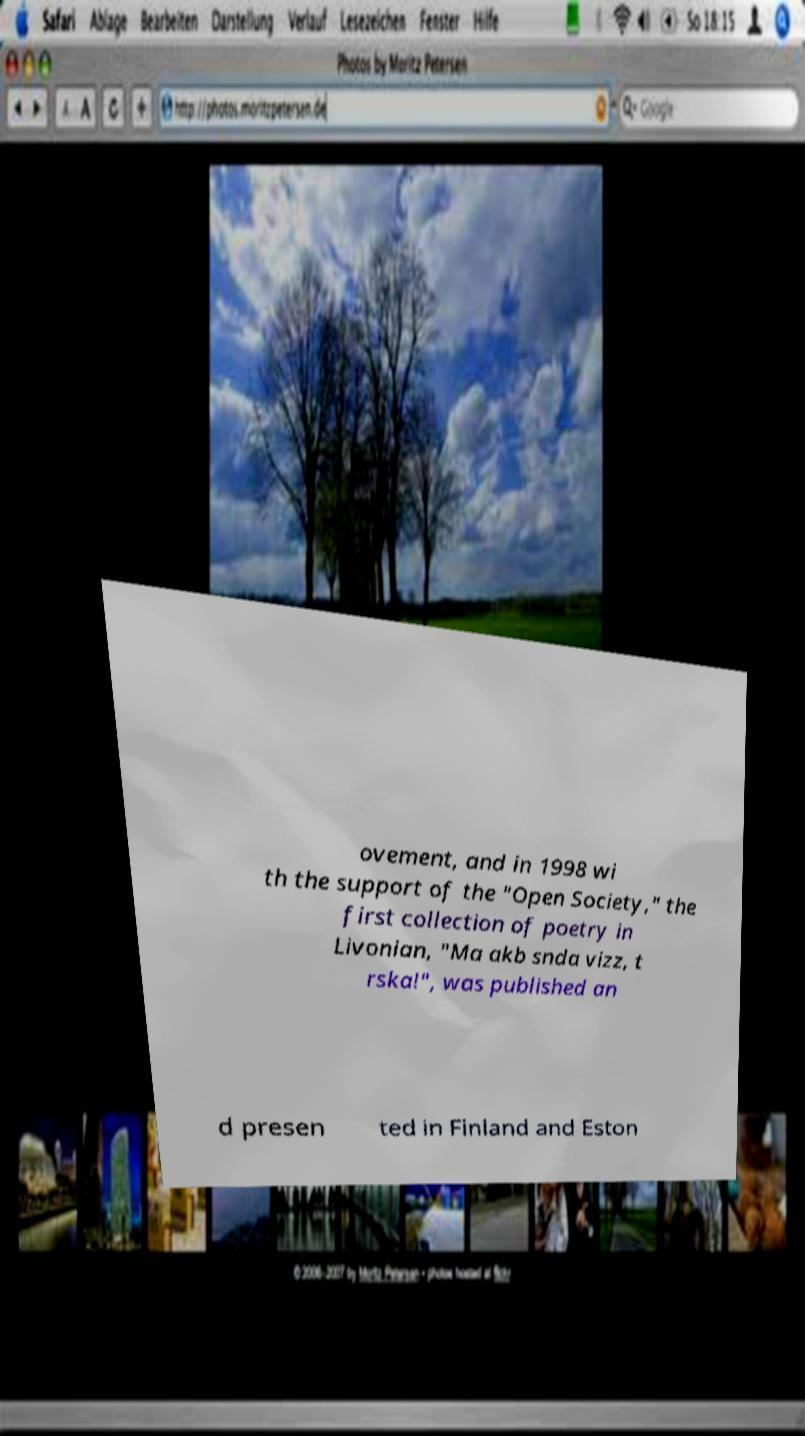What messages or text are displayed in this image? I need them in a readable, typed format. ovement, and in 1998 wi th the support of the "Open Society," the first collection of poetry in Livonian, "Ma akb snda vizz, t rska!", was published an d presen ted in Finland and Eston 